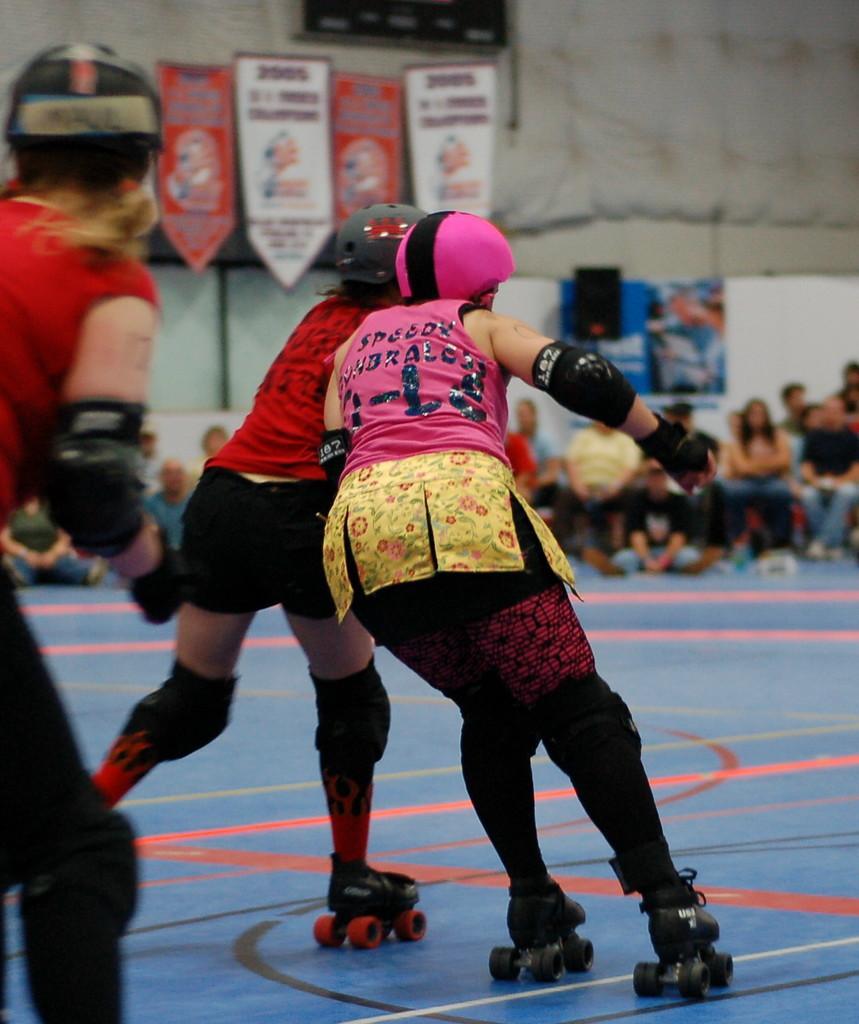Could you give a brief overview of what you see in this image? In this image I can see few people with helmets and the skate-wheels. In the background I can see the group of people with different color dresses, many boards and the wall. 